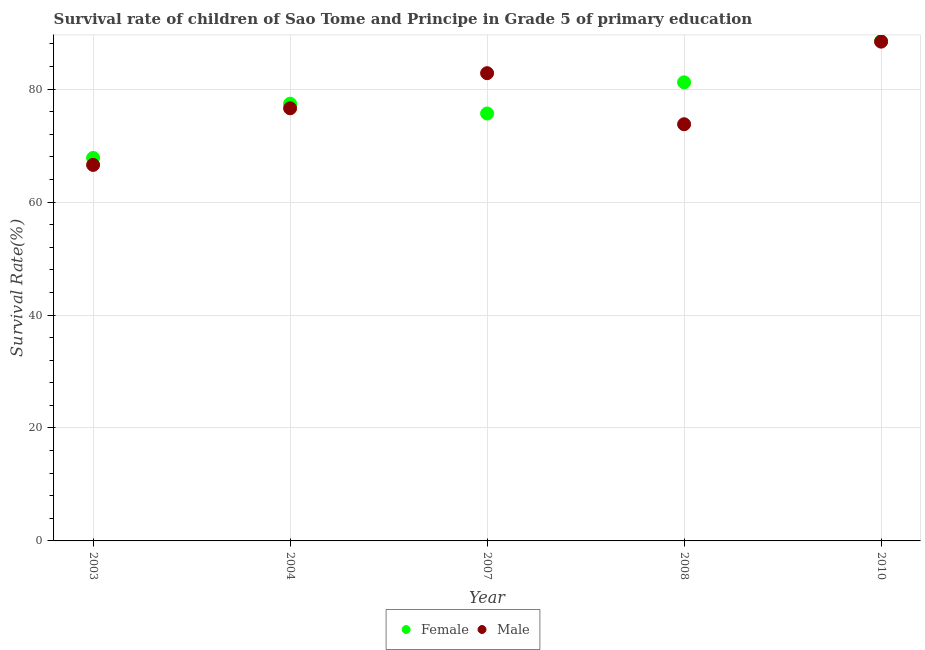How many different coloured dotlines are there?
Give a very brief answer. 2. What is the survival rate of female students in primary education in 2007?
Give a very brief answer. 75.69. Across all years, what is the maximum survival rate of female students in primary education?
Your response must be concise. 88.52. Across all years, what is the minimum survival rate of female students in primary education?
Your answer should be very brief. 67.82. In which year was the survival rate of male students in primary education minimum?
Provide a short and direct response. 2003. What is the total survival rate of male students in primary education in the graph?
Offer a very short reply. 388.24. What is the difference between the survival rate of female students in primary education in 2007 and that in 2008?
Your answer should be compact. -5.52. What is the difference between the survival rate of female students in primary education in 2003 and the survival rate of male students in primary education in 2010?
Your answer should be compact. -20.6. What is the average survival rate of male students in primary education per year?
Make the answer very short. 77.65. In the year 2008, what is the difference between the survival rate of male students in primary education and survival rate of female students in primary education?
Give a very brief answer. -7.42. In how many years, is the survival rate of male students in primary education greater than 84 %?
Keep it short and to the point. 1. What is the ratio of the survival rate of male students in primary education in 2003 to that in 2010?
Provide a succinct answer. 0.75. Is the survival rate of female students in primary education in 2003 less than that in 2008?
Provide a short and direct response. Yes. Is the difference between the survival rate of female students in primary education in 2003 and 2008 greater than the difference between the survival rate of male students in primary education in 2003 and 2008?
Your response must be concise. No. What is the difference between the highest and the second highest survival rate of male students in primary education?
Your answer should be very brief. 5.59. What is the difference between the highest and the lowest survival rate of female students in primary education?
Give a very brief answer. 20.7. In how many years, is the survival rate of male students in primary education greater than the average survival rate of male students in primary education taken over all years?
Your answer should be very brief. 2. Is the survival rate of female students in primary education strictly greater than the survival rate of male students in primary education over the years?
Your response must be concise. No. What is the difference between two consecutive major ticks on the Y-axis?
Your response must be concise. 20. Does the graph contain any zero values?
Give a very brief answer. No. Does the graph contain grids?
Ensure brevity in your answer.  Yes. How many legend labels are there?
Provide a short and direct response. 2. What is the title of the graph?
Offer a very short reply. Survival rate of children of Sao Tome and Principe in Grade 5 of primary education. What is the label or title of the X-axis?
Your answer should be compact. Year. What is the label or title of the Y-axis?
Offer a very short reply. Survival Rate(%). What is the Survival Rate(%) of Female in 2003?
Make the answer very short. 67.82. What is the Survival Rate(%) of Male in 2003?
Your answer should be very brief. 66.59. What is the Survival Rate(%) of Female in 2004?
Your answer should be compact. 77.43. What is the Survival Rate(%) of Male in 2004?
Your answer should be compact. 76.61. What is the Survival Rate(%) of Female in 2007?
Provide a succinct answer. 75.69. What is the Survival Rate(%) in Male in 2007?
Offer a very short reply. 82.83. What is the Survival Rate(%) in Female in 2008?
Give a very brief answer. 81.21. What is the Survival Rate(%) of Male in 2008?
Your response must be concise. 73.79. What is the Survival Rate(%) of Female in 2010?
Your answer should be very brief. 88.52. What is the Survival Rate(%) of Male in 2010?
Your response must be concise. 88.42. Across all years, what is the maximum Survival Rate(%) in Female?
Your answer should be very brief. 88.52. Across all years, what is the maximum Survival Rate(%) in Male?
Offer a very short reply. 88.42. Across all years, what is the minimum Survival Rate(%) of Female?
Your answer should be very brief. 67.82. Across all years, what is the minimum Survival Rate(%) in Male?
Ensure brevity in your answer.  66.59. What is the total Survival Rate(%) of Female in the graph?
Ensure brevity in your answer.  390.67. What is the total Survival Rate(%) of Male in the graph?
Provide a short and direct response. 388.24. What is the difference between the Survival Rate(%) of Female in 2003 and that in 2004?
Keep it short and to the point. -9.61. What is the difference between the Survival Rate(%) in Male in 2003 and that in 2004?
Make the answer very short. -10.02. What is the difference between the Survival Rate(%) in Female in 2003 and that in 2007?
Offer a very short reply. -7.88. What is the difference between the Survival Rate(%) of Male in 2003 and that in 2007?
Offer a very short reply. -16.24. What is the difference between the Survival Rate(%) of Female in 2003 and that in 2008?
Make the answer very short. -13.39. What is the difference between the Survival Rate(%) in Male in 2003 and that in 2008?
Ensure brevity in your answer.  -7.2. What is the difference between the Survival Rate(%) in Female in 2003 and that in 2010?
Your answer should be very brief. -20.7. What is the difference between the Survival Rate(%) of Male in 2003 and that in 2010?
Give a very brief answer. -21.83. What is the difference between the Survival Rate(%) in Female in 2004 and that in 2007?
Make the answer very short. 1.73. What is the difference between the Survival Rate(%) in Male in 2004 and that in 2007?
Ensure brevity in your answer.  -6.22. What is the difference between the Survival Rate(%) in Female in 2004 and that in 2008?
Provide a succinct answer. -3.78. What is the difference between the Survival Rate(%) of Male in 2004 and that in 2008?
Your answer should be very brief. 2.82. What is the difference between the Survival Rate(%) of Female in 2004 and that in 2010?
Offer a terse response. -11.09. What is the difference between the Survival Rate(%) of Male in 2004 and that in 2010?
Your answer should be very brief. -11.81. What is the difference between the Survival Rate(%) of Female in 2007 and that in 2008?
Keep it short and to the point. -5.52. What is the difference between the Survival Rate(%) of Male in 2007 and that in 2008?
Provide a short and direct response. 9.04. What is the difference between the Survival Rate(%) in Female in 2007 and that in 2010?
Your answer should be very brief. -12.82. What is the difference between the Survival Rate(%) in Male in 2007 and that in 2010?
Offer a very short reply. -5.59. What is the difference between the Survival Rate(%) in Female in 2008 and that in 2010?
Ensure brevity in your answer.  -7.31. What is the difference between the Survival Rate(%) in Male in 2008 and that in 2010?
Provide a short and direct response. -14.63. What is the difference between the Survival Rate(%) in Female in 2003 and the Survival Rate(%) in Male in 2004?
Offer a very short reply. -8.79. What is the difference between the Survival Rate(%) in Female in 2003 and the Survival Rate(%) in Male in 2007?
Provide a short and direct response. -15.01. What is the difference between the Survival Rate(%) in Female in 2003 and the Survival Rate(%) in Male in 2008?
Your answer should be very brief. -5.97. What is the difference between the Survival Rate(%) in Female in 2003 and the Survival Rate(%) in Male in 2010?
Ensure brevity in your answer.  -20.6. What is the difference between the Survival Rate(%) in Female in 2004 and the Survival Rate(%) in Male in 2007?
Ensure brevity in your answer.  -5.4. What is the difference between the Survival Rate(%) in Female in 2004 and the Survival Rate(%) in Male in 2008?
Offer a terse response. 3.64. What is the difference between the Survival Rate(%) in Female in 2004 and the Survival Rate(%) in Male in 2010?
Your response must be concise. -10.99. What is the difference between the Survival Rate(%) in Female in 2007 and the Survival Rate(%) in Male in 2008?
Your response must be concise. 1.91. What is the difference between the Survival Rate(%) of Female in 2007 and the Survival Rate(%) of Male in 2010?
Offer a terse response. -12.72. What is the difference between the Survival Rate(%) in Female in 2008 and the Survival Rate(%) in Male in 2010?
Keep it short and to the point. -7.21. What is the average Survival Rate(%) in Female per year?
Give a very brief answer. 78.13. What is the average Survival Rate(%) in Male per year?
Keep it short and to the point. 77.65. In the year 2003, what is the difference between the Survival Rate(%) of Female and Survival Rate(%) of Male?
Offer a very short reply. 1.23. In the year 2004, what is the difference between the Survival Rate(%) in Female and Survival Rate(%) in Male?
Keep it short and to the point. 0.82. In the year 2007, what is the difference between the Survival Rate(%) of Female and Survival Rate(%) of Male?
Ensure brevity in your answer.  -7.14. In the year 2008, what is the difference between the Survival Rate(%) in Female and Survival Rate(%) in Male?
Ensure brevity in your answer.  7.42. In the year 2010, what is the difference between the Survival Rate(%) in Female and Survival Rate(%) in Male?
Offer a terse response. 0.1. What is the ratio of the Survival Rate(%) in Female in 2003 to that in 2004?
Your answer should be compact. 0.88. What is the ratio of the Survival Rate(%) of Male in 2003 to that in 2004?
Make the answer very short. 0.87. What is the ratio of the Survival Rate(%) of Female in 2003 to that in 2007?
Offer a terse response. 0.9. What is the ratio of the Survival Rate(%) of Male in 2003 to that in 2007?
Your answer should be compact. 0.8. What is the ratio of the Survival Rate(%) in Female in 2003 to that in 2008?
Your answer should be compact. 0.84. What is the ratio of the Survival Rate(%) in Male in 2003 to that in 2008?
Provide a short and direct response. 0.9. What is the ratio of the Survival Rate(%) of Female in 2003 to that in 2010?
Give a very brief answer. 0.77. What is the ratio of the Survival Rate(%) in Male in 2003 to that in 2010?
Offer a very short reply. 0.75. What is the ratio of the Survival Rate(%) of Female in 2004 to that in 2007?
Your answer should be compact. 1.02. What is the ratio of the Survival Rate(%) in Male in 2004 to that in 2007?
Ensure brevity in your answer.  0.92. What is the ratio of the Survival Rate(%) in Female in 2004 to that in 2008?
Make the answer very short. 0.95. What is the ratio of the Survival Rate(%) in Male in 2004 to that in 2008?
Give a very brief answer. 1.04. What is the ratio of the Survival Rate(%) of Female in 2004 to that in 2010?
Keep it short and to the point. 0.87. What is the ratio of the Survival Rate(%) in Male in 2004 to that in 2010?
Offer a very short reply. 0.87. What is the ratio of the Survival Rate(%) of Female in 2007 to that in 2008?
Give a very brief answer. 0.93. What is the ratio of the Survival Rate(%) in Male in 2007 to that in 2008?
Offer a very short reply. 1.12. What is the ratio of the Survival Rate(%) in Female in 2007 to that in 2010?
Make the answer very short. 0.86. What is the ratio of the Survival Rate(%) of Male in 2007 to that in 2010?
Offer a very short reply. 0.94. What is the ratio of the Survival Rate(%) in Female in 2008 to that in 2010?
Give a very brief answer. 0.92. What is the ratio of the Survival Rate(%) in Male in 2008 to that in 2010?
Your answer should be compact. 0.83. What is the difference between the highest and the second highest Survival Rate(%) in Female?
Keep it short and to the point. 7.31. What is the difference between the highest and the second highest Survival Rate(%) in Male?
Offer a terse response. 5.59. What is the difference between the highest and the lowest Survival Rate(%) in Female?
Provide a succinct answer. 20.7. What is the difference between the highest and the lowest Survival Rate(%) of Male?
Your answer should be compact. 21.83. 